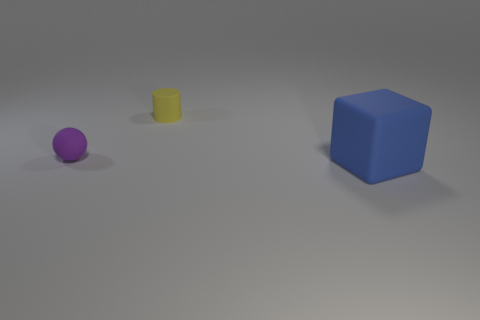What could be the possible use of these objects in a setting? The objects could function as educational aids to teach concepts such as geometry, color differentiation, or size scaling. Additionally, they might be used in creative design and art settings for spatial arrangement or as reference objects for 3D modeling. How could these objects be arranged to create an aesthetically pleasing composition? One might arrange them in a linear gradient of size, creating a visual flow from the smallest to the largest object. Alternatively, they could be grouped by their vibrant colors to generate a compelling, balanced color palette. 